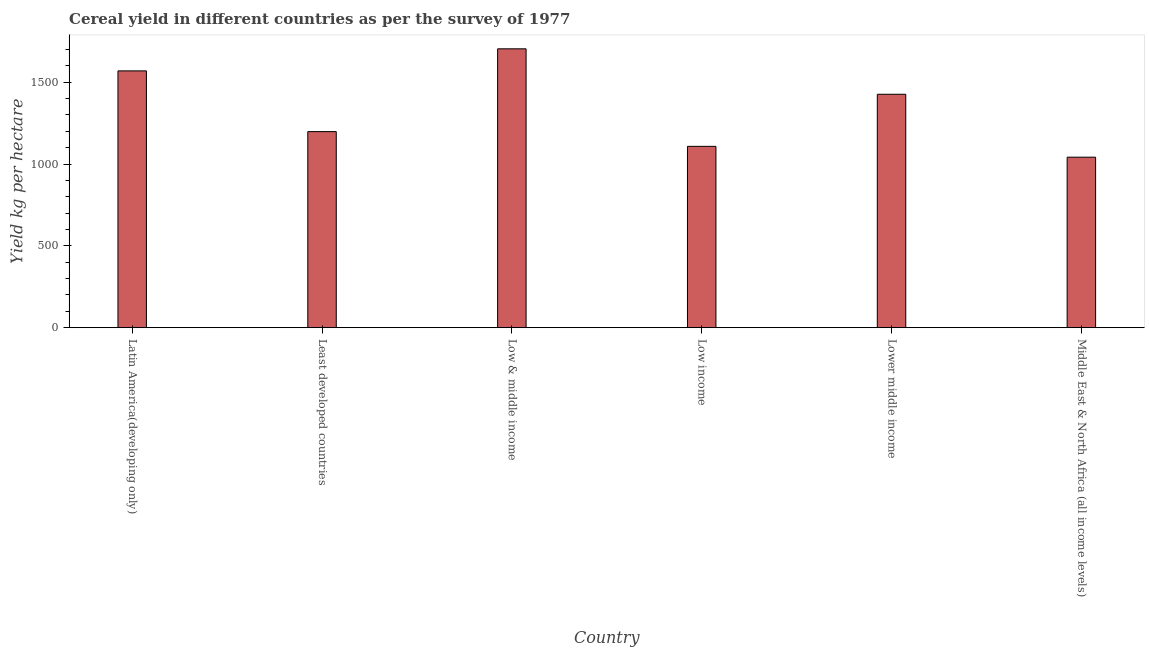Does the graph contain any zero values?
Give a very brief answer. No. What is the title of the graph?
Make the answer very short. Cereal yield in different countries as per the survey of 1977. What is the label or title of the Y-axis?
Your response must be concise. Yield kg per hectare. What is the cereal yield in Middle East & North Africa (all income levels)?
Your answer should be compact. 1041.79. Across all countries, what is the maximum cereal yield?
Ensure brevity in your answer.  1703.97. Across all countries, what is the minimum cereal yield?
Your response must be concise. 1041.79. In which country was the cereal yield maximum?
Make the answer very short. Low & middle income. In which country was the cereal yield minimum?
Provide a short and direct response. Middle East & North Africa (all income levels). What is the sum of the cereal yield?
Provide a succinct answer. 8047.14. What is the difference between the cereal yield in Low & middle income and Lower middle income?
Ensure brevity in your answer.  277.7. What is the average cereal yield per country?
Give a very brief answer. 1341.19. What is the median cereal yield?
Ensure brevity in your answer.  1312.13. In how many countries, is the cereal yield greater than 500 kg per hectare?
Your response must be concise. 6. What is the ratio of the cereal yield in Latin America(developing only) to that in Lower middle income?
Ensure brevity in your answer.  1.1. What is the difference between the highest and the second highest cereal yield?
Offer a very short reply. 134.86. What is the difference between the highest and the lowest cereal yield?
Give a very brief answer. 662.18. In how many countries, is the cereal yield greater than the average cereal yield taken over all countries?
Your answer should be very brief. 3. What is the Yield kg per hectare of Latin America(developing only)?
Provide a short and direct response. 1569.11. What is the Yield kg per hectare in Least developed countries?
Provide a short and direct response. 1197.98. What is the Yield kg per hectare of Low & middle income?
Provide a short and direct response. 1703.97. What is the Yield kg per hectare in Low income?
Provide a short and direct response. 1108. What is the Yield kg per hectare in Lower middle income?
Your response must be concise. 1426.27. What is the Yield kg per hectare in Middle East & North Africa (all income levels)?
Give a very brief answer. 1041.79. What is the difference between the Yield kg per hectare in Latin America(developing only) and Least developed countries?
Keep it short and to the point. 371.13. What is the difference between the Yield kg per hectare in Latin America(developing only) and Low & middle income?
Your response must be concise. -134.86. What is the difference between the Yield kg per hectare in Latin America(developing only) and Low income?
Your response must be concise. 461.12. What is the difference between the Yield kg per hectare in Latin America(developing only) and Lower middle income?
Keep it short and to the point. 142.84. What is the difference between the Yield kg per hectare in Latin America(developing only) and Middle East & North Africa (all income levels)?
Your answer should be very brief. 527.32. What is the difference between the Yield kg per hectare in Least developed countries and Low & middle income?
Offer a terse response. -505.99. What is the difference between the Yield kg per hectare in Least developed countries and Low income?
Offer a very short reply. 89.99. What is the difference between the Yield kg per hectare in Least developed countries and Lower middle income?
Offer a very short reply. -228.29. What is the difference between the Yield kg per hectare in Least developed countries and Middle East & North Africa (all income levels)?
Ensure brevity in your answer.  156.19. What is the difference between the Yield kg per hectare in Low & middle income and Low income?
Your response must be concise. 595.98. What is the difference between the Yield kg per hectare in Low & middle income and Lower middle income?
Keep it short and to the point. 277.7. What is the difference between the Yield kg per hectare in Low & middle income and Middle East & North Africa (all income levels)?
Make the answer very short. 662.18. What is the difference between the Yield kg per hectare in Low income and Lower middle income?
Offer a terse response. -318.28. What is the difference between the Yield kg per hectare in Low income and Middle East & North Africa (all income levels)?
Make the answer very short. 66.2. What is the difference between the Yield kg per hectare in Lower middle income and Middle East & North Africa (all income levels)?
Keep it short and to the point. 384.48. What is the ratio of the Yield kg per hectare in Latin America(developing only) to that in Least developed countries?
Offer a very short reply. 1.31. What is the ratio of the Yield kg per hectare in Latin America(developing only) to that in Low & middle income?
Offer a terse response. 0.92. What is the ratio of the Yield kg per hectare in Latin America(developing only) to that in Low income?
Keep it short and to the point. 1.42. What is the ratio of the Yield kg per hectare in Latin America(developing only) to that in Middle East & North Africa (all income levels)?
Your answer should be very brief. 1.51. What is the ratio of the Yield kg per hectare in Least developed countries to that in Low & middle income?
Your answer should be very brief. 0.7. What is the ratio of the Yield kg per hectare in Least developed countries to that in Low income?
Provide a short and direct response. 1.08. What is the ratio of the Yield kg per hectare in Least developed countries to that in Lower middle income?
Provide a short and direct response. 0.84. What is the ratio of the Yield kg per hectare in Least developed countries to that in Middle East & North Africa (all income levels)?
Ensure brevity in your answer.  1.15. What is the ratio of the Yield kg per hectare in Low & middle income to that in Low income?
Your response must be concise. 1.54. What is the ratio of the Yield kg per hectare in Low & middle income to that in Lower middle income?
Your answer should be compact. 1.2. What is the ratio of the Yield kg per hectare in Low & middle income to that in Middle East & North Africa (all income levels)?
Make the answer very short. 1.64. What is the ratio of the Yield kg per hectare in Low income to that in Lower middle income?
Keep it short and to the point. 0.78. What is the ratio of the Yield kg per hectare in Low income to that in Middle East & North Africa (all income levels)?
Ensure brevity in your answer.  1.06. What is the ratio of the Yield kg per hectare in Lower middle income to that in Middle East & North Africa (all income levels)?
Ensure brevity in your answer.  1.37. 